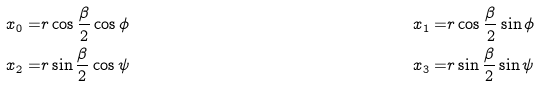Convert formula to latex. <formula><loc_0><loc_0><loc_500><loc_500>x _ { 0 } = & r \cos \frac { \beta } { 2 } \cos \phi & x _ { 1 } = & r \cos \frac { \beta } { 2 } \sin \phi \\ x _ { 2 } = & r \sin \frac { \beta } { 2 } \cos \psi & x _ { 3 } = & r \sin \frac { \beta } { 2 } \sin \psi</formula> 